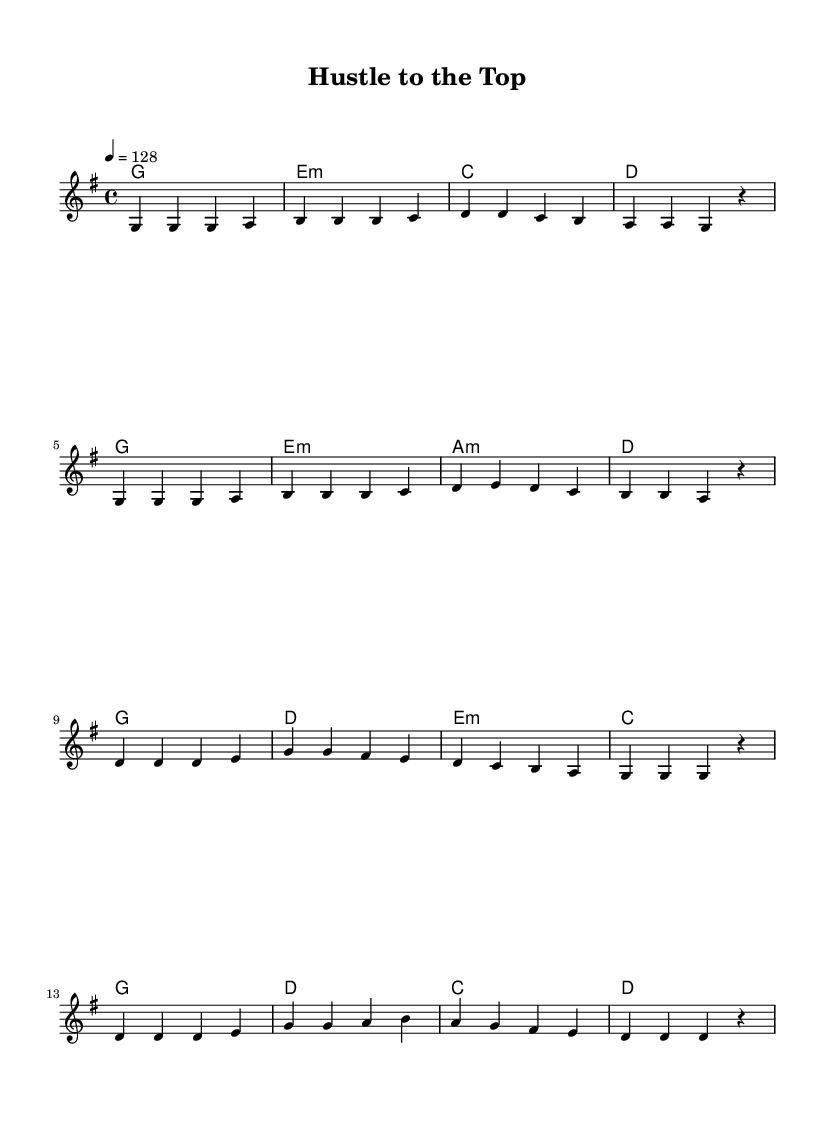What is the key signature of this music? The key signature is G major, which has one sharp (F#).
Answer: G major What is the time signature of this music? The time signature is 4/4, indicating four beats per measure.
Answer: 4/4 What is the tempo marking given in this piece? The tempo marking is 128 beats per minute, indicating a lively pace.
Answer: 128 How many measures are there in the verse section? The verse section consists of 8 measures as indicated by the music notation.
Answer: 8 Which chord follows the B chord in the verse? In the verse, after the B chord comes the C chord, as discerned by the chord progression.
Answer: C What is the main theme of this K-Pop song? The main theme revolves around business success and entrepreneurship, emphasized by the title "Hustle to the Top."
Answer: Business success How does the melody of the chorus alternate between notes? The melody of the chorus primarily alternates between the notes D, E, and G, creating an energetic feeling typical of K-Pop.
Answer: D, E, G 